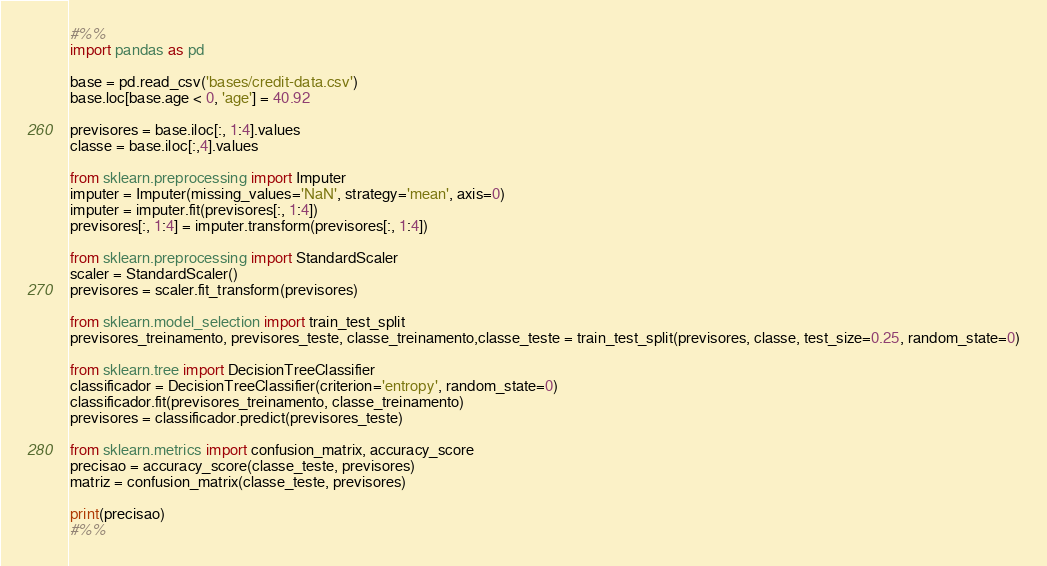Convert code to text. <code><loc_0><loc_0><loc_500><loc_500><_Python_>#%%
import pandas as pd

base = pd.read_csv('bases/credit-data.csv')
base.loc[base.age < 0, 'age'] = 40.92

previsores = base.iloc[:, 1:4].values
classe = base.iloc[:,4].values

from sklearn.preprocessing import Imputer
imputer = Imputer(missing_values='NaN', strategy='mean', axis=0)
imputer = imputer.fit(previsores[:, 1:4])
previsores[:, 1:4] = imputer.transform(previsores[:, 1:4])

from sklearn.preprocessing import StandardScaler
scaler = StandardScaler()
previsores = scaler.fit_transform(previsores)

from sklearn.model_selection import train_test_split
previsores_treinamento, previsores_teste, classe_treinamento,classe_teste = train_test_split(previsores, classe, test_size=0.25, random_state=0)

from sklearn.tree import DecisionTreeClassifier
classificador = DecisionTreeClassifier(criterion='entropy', random_state=0)
classificador.fit(previsores_treinamento, classe_treinamento)
previsores = classificador.predict(previsores_teste)

from sklearn.metrics import confusion_matrix, accuracy_score
precisao = accuracy_score(classe_teste, previsores)
matriz = confusion_matrix(classe_teste, previsores)

print(precisao)
#%%
</code> 